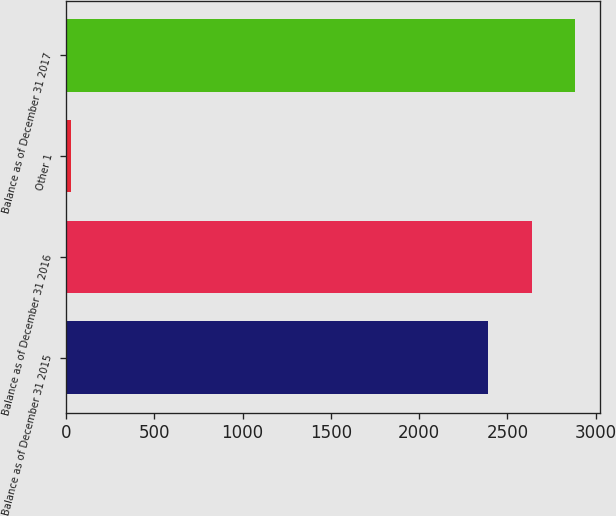Convert chart. <chart><loc_0><loc_0><loc_500><loc_500><bar_chart><fcel>Balance as of December 31 2015<fcel>Balance as of December 31 2016<fcel>Other 1<fcel>Balance as of December 31 2017<nl><fcel>2392<fcel>2637.7<fcel>27<fcel>2883.4<nl></chart> 